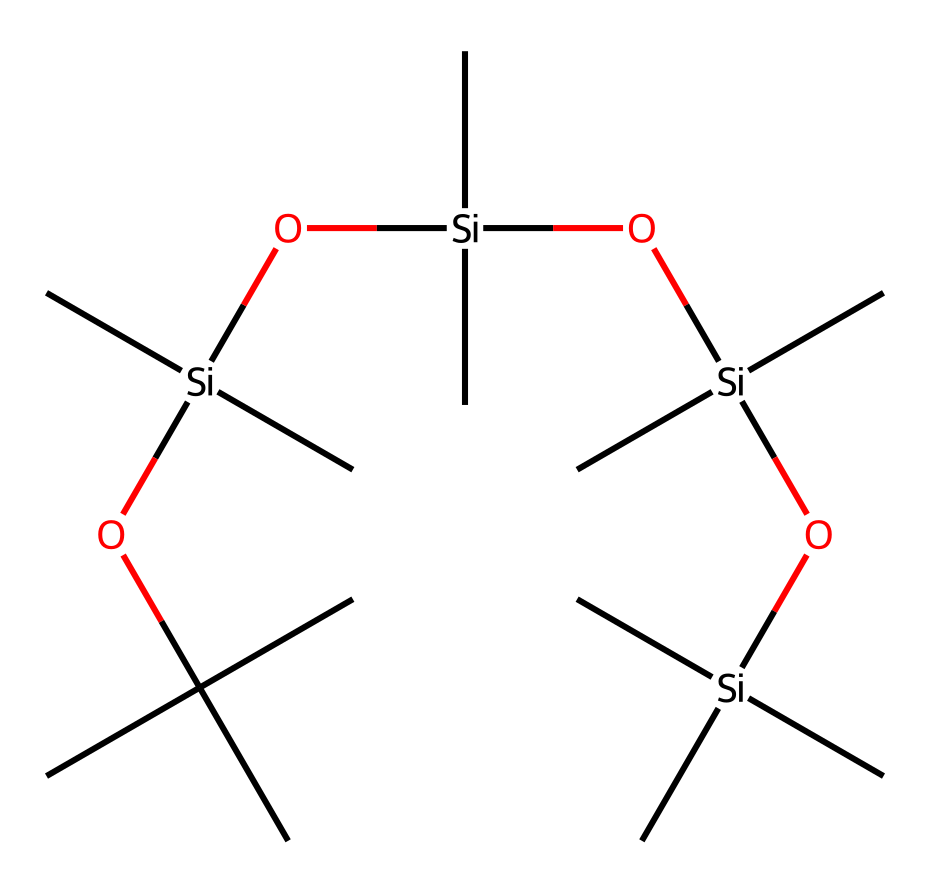What element is the backbone of this silicone compound? The SMILES representation shows a silicon (Si) atom as the central atom in the structure, indicating that silicon is the backbone.
Answer: silicon How many alkyl groups are attached to the silicon atoms? The structure includes multiple groups of branching carbon chains (C) attached to each silicon atom; counting these shows that there are twelve alkyl groups.
Answer: twelve What is the longest carbon chain in the structure? Looking at the SMILES, the longest carbon chain is part of the branched carbon structures, identified by the longest continuous sequence of carbon atoms, which consists of three carbons in straight chain.
Answer: three Is this compound likely to be hydrophobic? Given the presence of silicon and the alkyl groups, which are non-polar, this compound exhibits hydrophobic properties, meaning it repels water.
Answer: yes How many silicon atoms are present in the formula? The SMILES representation includes four distinct silicon atoms each connected to the alkyl and oxygen groups, which can be counted directly from the structure.
Answer: four What functional groups are indicated in this chemistry? The presence of oxygen (O) indicates the presence of silanol (Si-OH) and siloxane (Si-O-Si) groups, which are characteristic functional groups in organosilicon compounds.
Answer: silanol and siloxane What characteristic property does the presence of siloxane linkages impart to this gel? Siloxane linkages in organosilicon compounds provide flexibility and resilience to the material, making it suitable for use in hair gels.
Answer: flexibility 